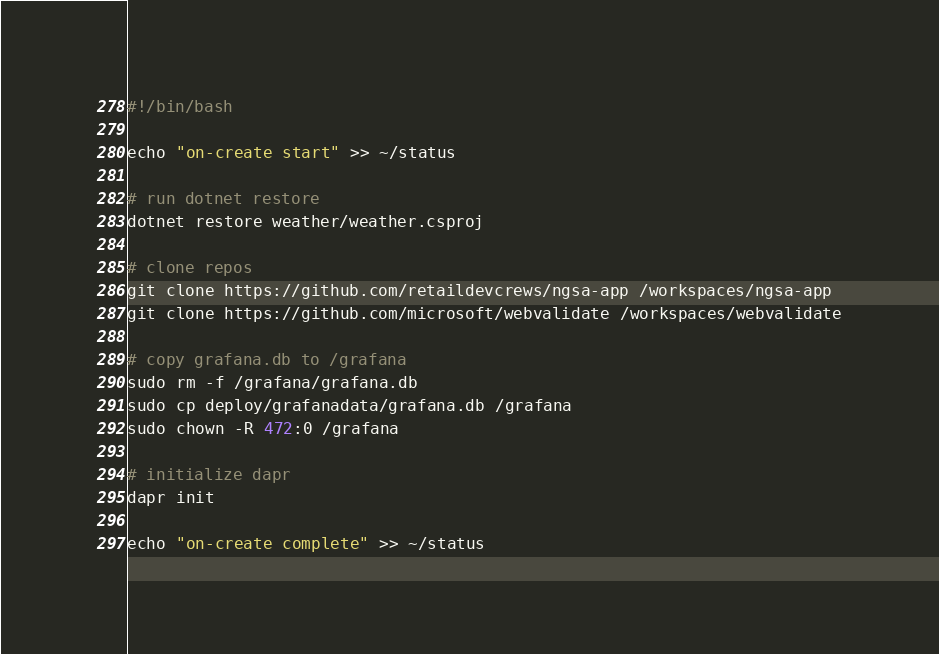Convert code to text. <code><loc_0><loc_0><loc_500><loc_500><_Bash_>#!/bin/bash

echo "on-create start" >> ~/status

# run dotnet restore
dotnet restore weather/weather.csproj 

# clone repos
git clone https://github.com/retaildevcrews/ngsa-app /workspaces/ngsa-app
git clone https://github.com/microsoft/webvalidate /workspaces/webvalidate

# copy grafana.db to /grafana
sudo rm -f /grafana/grafana.db
sudo cp deploy/grafanadata/grafana.db /grafana
sudo chown -R 472:0 /grafana

# initialize dapr
dapr init

echo "on-create complete" >> ~/status
</code> 